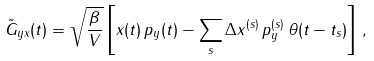Convert formula to latex. <formula><loc_0><loc_0><loc_500><loc_500>\tilde { G } _ { y x } ( t ) = \sqrt { \frac { \beta } { V } } \left [ x ( t ) \, p _ { y } ( t ) - \sum _ { s } \Delta x ^ { ( s ) } \, p _ { y } ^ { ( s ) } \, \theta ( t - t _ { s } ) \right ] \, ,</formula> 